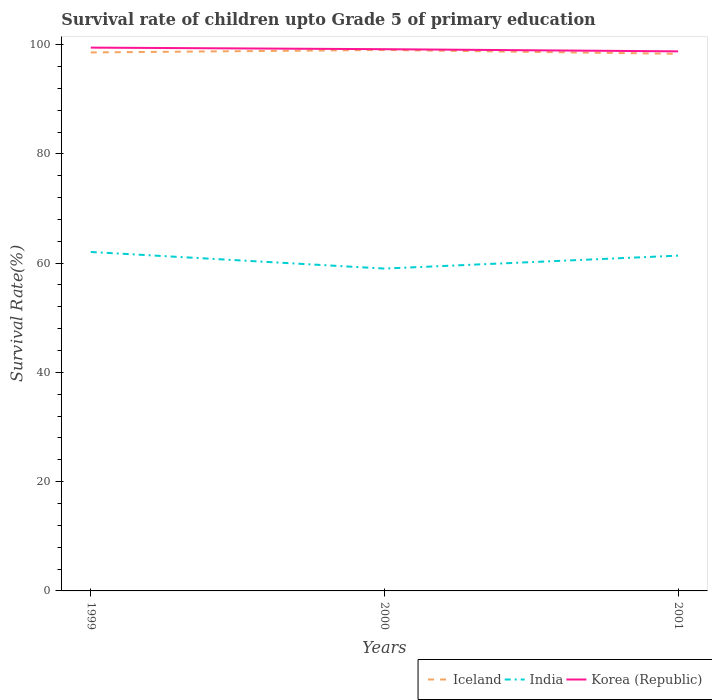Is the number of lines equal to the number of legend labels?
Make the answer very short. Yes. Across all years, what is the maximum survival rate of children in Iceland?
Ensure brevity in your answer.  98.32. What is the total survival rate of children in Iceland in the graph?
Keep it short and to the point. -0.45. What is the difference between the highest and the second highest survival rate of children in India?
Keep it short and to the point. 3.04. Is the survival rate of children in Korea (Republic) strictly greater than the survival rate of children in Iceland over the years?
Your response must be concise. No. How many lines are there?
Offer a very short reply. 3. How many years are there in the graph?
Keep it short and to the point. 3. What is the difference between two consecutive major ticks on the Y-axis?
Your answer should be very brief. 20. Does the graph contain any zero values?
Offer a very short reply. No. Does the graph contain grids?
Your answer should be compact. No. Where does the legend appear in the graph?
Keep it short and to the point. Bottom right. How many legend labels are there?
Offer a very short reply. 3. How are the legend labels stacked?
Offer a very short reply. Horizontal. What is the title of the graph?
Offer a very short reply. Survival rate of children upto Grade 5 of primary education. Does "Costa Rica" appear as one of the legend labels in the graph?
Give a very brief answer. No. What is the label or title of the Y-axis?
Ensure brevity in your answer.  Survival Rate(%). What is the Survival Rate(%) in Iceland in 1999?
Provide a succinct answer. 98.57. What is the Survival Rate(%) of India in 1999?
Your answer should be compact. 62.05. What is the Survival Rate(%) of Korea (Republic) in 1999?
Offer a terse response. 99.45. What is the Survival Rate(%) of Iceland in 2000?
Keep it short and to the point. 99.02. What is the Survival Rate(%) of India in 2000?
Offer a terse response. 59.01. What is the Survival Rate(%) in Korea (Republic) in 2000?
Your answer should be compact. 99.17. What is the Survival Rate(%) of Iceland in 2001?
Ensure brevity in your answer.  98.32. What is the Survival Rate(%) of India in 2001?
Your response must be concise. 61.37. What is the Survival Rate(%) of Korea (Republic) in 2001?
Offer a very short reply. 98.77. Across all years, what is the maximum Survival Rate(%) in Iceland?
Your answer should be very brief. 99.02. Across all years, what is the maximum Survival Rate(%) of India?
Provide a short and direct response. 62.05. Across all years, what is the maximum Survival Rate(%) in Korea (Republic)?
Keep it short and to the point. 99.45. Across all years, what is the minimum Survival Rate(%) in Iceland?
Your response must be concise. 98.32. Across all years, what is the minimum Survival Rate(%) of India?
Your answer should be very brief. 59.01. Across all years, what is the minimum Survival Rate(%) of Korea (Republic)?
Make the answer very short. 98.77. What is the total Survival Rate(%) in Iceland in the graph?
Your answer should be very brief. 295.92. What is the total Survival Rate(%) in India in the graph?
Your response must be concise. 182.43. What is the total Survival Rate(%) in Korea (Republic) in the graph?
Your response must be concise. 297.38. What is the difference between the Survival Rate(%) of Iceland in 1999 and that in 2000?
Offer a very short reply. -0.45. What is the difference between the Survival Rate(%) of India in 1999 and that in 2000?
Keep it short and to the point. 3.04. What is the difference between the Survival Rate(%) in Korea (Republic) in 1999 and that in 2000?
Keep it short and to the point. 0.29. What is the difference between the Survival Rate(%) in Iceland in 1999 and that in 2001?
Provide a succinct answer. 0.25. What is the difference between the Survival Rate(%) of India in 1999 and that in 2001?
Make the answer very short. 0.67. What is the difference between the Survival Rate(%) in Korea (Republic) in 1999 and that in 2001?
Provide a succinct answer. 0.68. What is the difference between the Survival Rate(%) of Iceland in 2000 and that in 2001?
Provide a succinct answer. 0.7. What is the difference between the Survival Rate(%) in India in 2000 and that in 2001?
Your answer should be very brief. -2.37. What is the difference between the Survival Rate(%) in Korea (Republic) in 2000 and that in 2001?
Make the answer very short. 0.4. What is the difference between the Survival Rate(%) of Iceland in 1999 and the Survival Rate(%) of India in 2000?
Offer a terse response. 39.57. What is the difference between the Survival Rate(%) of Iceland in 1999 and the Survival Rate(%) of Korea (Republic) in 2000?
Provide a succinct answer. -0.59. What is the difference between the Survival Rate(%) of India in 1999 and the Survival Rate(%) of Korea (Republic) in 2000?
Make the answer very short. -37.12. What is the difference between the Survival Rate(%) of Iceland in 1999 and the Survival Rate(%) of India in 2001?
Keep it short and to the point. 37.2. What is the difference between the Survival Rate(%) of Iceland in 1999 and the Survival Rate(%) of Korea (Republic) in 2001?
Your answer should be compact. -0.2. What is the difference between the Survival Rate(%) in India in 1999 and the Survival Rate(%) in Korea (Republic) in 2001?
Offer a very short reply. -36.72. What is the difference between the Survival Rate(%) in Iceland in 2000 and the Survival Rate(%) in India in 2001?
Your answer should be very brief. 37.65. What is the difference between the Survival Rate(%) in Iceland in 2000 and the Survival Rate(%) in Korea (Republic) in 2001?
Make the answer very short. 0.26. What is the difference between the Survival Rate(%) in India in 2000 and the Survival Rate(%) in Korea (Republic) in 2001?
Make the answer very short. -39.76. What is the average Survival Rate(%) in Iceland per year?
Give a very brief answer. 98.64. What is the average Survival Rate(%) in India per year?
Your response must be concise. 60.81. What is the average Survival Rate(%) in Korea (Republic) per year?
Provide a short and direct response. 99.13. In the year 1999, what is the difference between the Survival Rate(%) of Iceland and Survival Rate(%) of India?
Ensure brevity in your answer.  36.53. In the year 1999, what is the difference between the Survival Rate(%) in Iceland and Survival Rate(%) in Korea (Republic)?
Provide a short and direct response. -0.88. In the year 1999, what is the difference between the Survival Rate(%) in India and Survival Rate(%) in Korea (Republic)?
Keep it short and to the point. -37.41. In the year 2000, what is the difference between the Survival Rate(%) in Iceland and Survival Rate(%) in India?
Provide a short and direct response. 40.02. In the year 2000, what is the difference between the Survival Rate(%) in Iceland and Survival Rate(%) in Korea (Republic)?
Your response must be concise. -0.14. In the year 2000, what is the difference between the Survival Rate(%) in India and Survival Rate(%) in Korea (Republic)?
Offer a very short reply. -40.16. In the year 2001, what is the difference between the Survival Rate(%) in Iceland and Survival Rate(%) in India?
Your answer should be very brief. 36.95. In the year 2001, what is the difference between the Survival Rate(%) in Iceland and Survival Rate(%) in Korea (Republic)?
Your response must be concise. -0.45. In the year 2001, what is the difference between the Survival Rate(%) of India and Survival Rate(%) of Korea (Republic)?
Give a very brief answer. -37.39. What is the ratio of the Survival Rate(%) in India in 1999 to that in 2000?
Your answer should be compact. 1.05. What is the ratio of the Survival Rate(%) of Korea (Republic) in 1999 to that in 2000?
Offer a very short reply. 1. What is the ratio of the Survival Rate(%) in India in 1999 to that in 2001?
Your answer should be compact. 1.01. What is the ratio of the Survival Rate(%) of Korea (Republic) in 1999 to that in 2001?
Offer a very short reply. 1.01. What is the ratio of the Survival Rate(%) in Iceland in 2000 to that in 2001?
Your answer should be compact. 1.01. What is the ratio of the Survival Rate(%) of India in 2000 to that in 2001?
Give a very brief answer. 0.96. What is the difference between the highest and the second highest Survival Rate(%) of Iceland?
Your answer should be very brief. 0.45. What is the difference between the highest and the second highest Survival Rate(%) of India?
Give a very brief answer. 0.67. What is the difference between the highest and the second highest Survival Rate(%) in Korea (Republic)?
Your answer should be very brief. 0.29. What is the difference between the highest and the lowest Survival Rate(%) of Iceland?
Provide a succinct answer. 0.7. What is the difference between the highest and the lowest Survival Rate(%) in India?
Keep it short and to the point. 3.04. What is the difference between the highest and the lowest Survival Rate(%) in Korea (Republic)?
Provide a succinct answer. 0.68. 